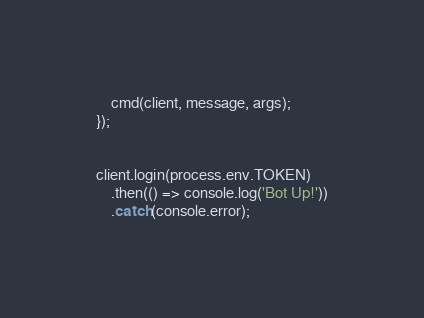Convert code to text. <code><loc_0><loc_0><loc_500><loc_500><_JavaScript_>    cmd(client, message, args);
});


client.login(process.env.TOKEN)
    .then(() => console.log('Bot Up!'))
    .catch(console.error);
</code> 